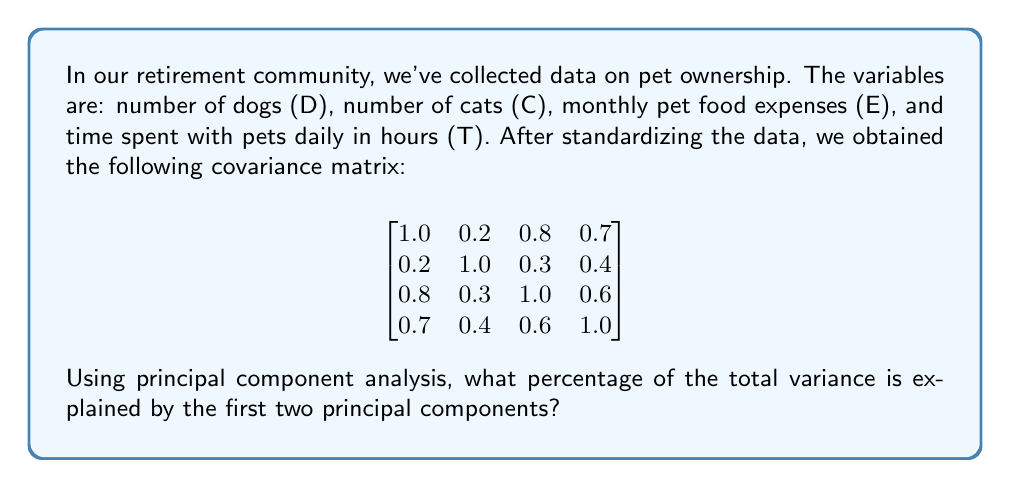What is the answer to this math problem? To solve this problem, we'll follow these steps:

1) First, we need to find the eigenvalues of the covariance matrix. These represent the variance explained by each principal component.

2) The characteristic equation is:
   $$det(\lambda I - A) = 0$$
   where $A$ is our covariance matrix and $I$ is the 4x4 identity matrix.

3) Solving this equation (which is a 4th degree polynomial) gives us the eigenvalues:
   $$\lambda_1 \approx 2.5245$$
   $$\lambda_2 \approx 0.8234$$
   $$\lambda_3 \approx 0.4252$$
   $$\lambda_4 \approx 0.2269$$

4) The total variance is the sum of all eigenvalues:
   $$2.5245 + 0.8234 + 0.4252 + 0.2269 = 4$$
   Note that this equals the trace of the covariance matrix, as expected.

5) The variance explained by the first two principal components is:
   $$2.5245 + 0.8234 = 3.3479$$

6) To get the percentage, we divide this by the total variance and multiply by 100:
   $$\frac{3.3479}{4} \times 100 \approx 83.70\%$$

Therefore, the first two principal components explain approximately 83.70% of the total variance.
Answer: 83.70% 